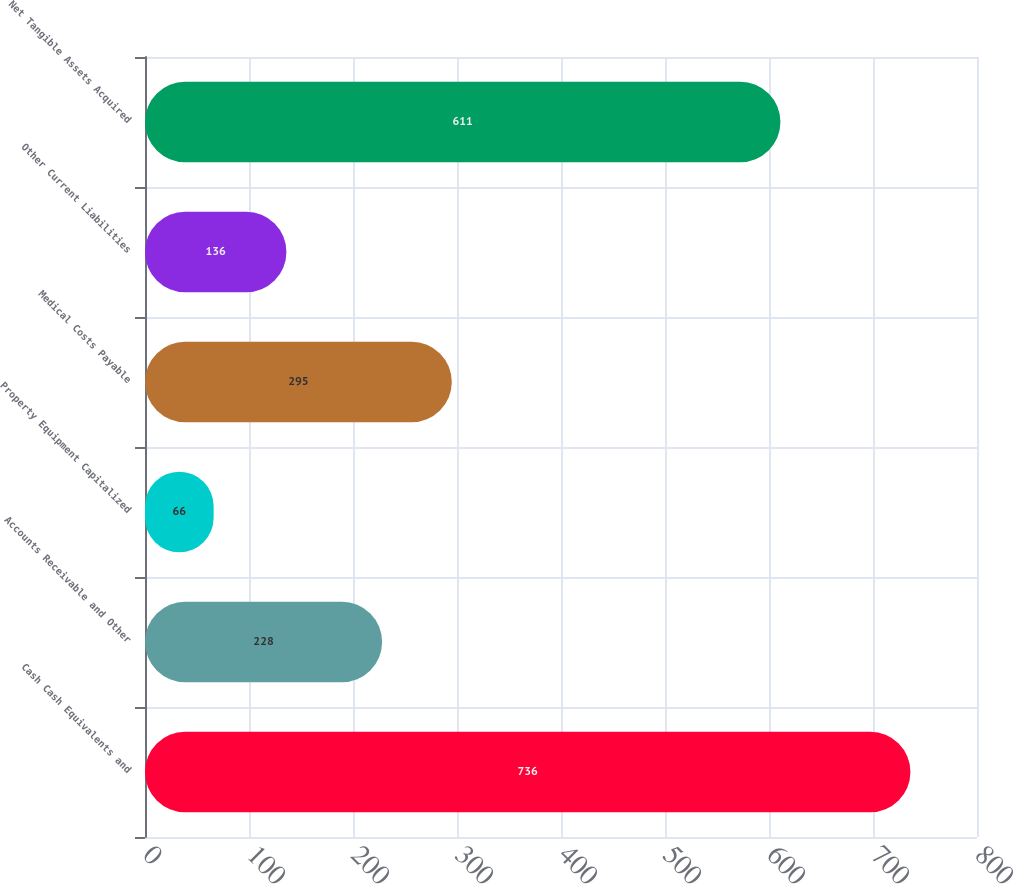<chart> <loc_0><loc_0><loc_500><loc_500><bar_chart><fcel>Cash Cash Equivalents and<fcel>Accounts Receivable and Other<fcel>Property Equipment Capitalized<fcel>Medical Costs Payable<fcel>Other Current Liabilities<fcel>Net Tangible Assets Acquired<nl><fcel>736<fcel>228<fcel>66<fcel>295<fcel>136<fcel>611<nl></chart> 